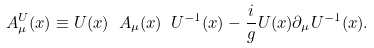<formula> <loc_0><loc_0><loc_500><loc_500>A ^ { U } _ { \mu } ( x ) \equiv U ( x ) \ A _ { \mu } ( x ) \ U ^ { - 1 } ( x ) - \frac { i } { g } U ( x ) \partial _ { \mu } U ^ { - 1 } ( x ) .</formula> 